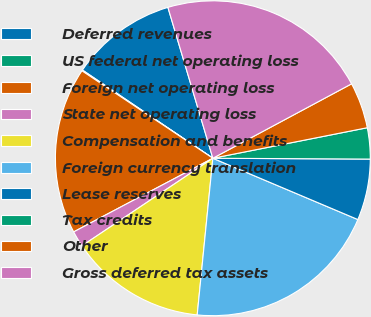Convert chart. <chart><loc_0><loc_0><loc_500><loc_500><pie_chart><fcel>Deferred revenues<fcel>US federal net operating loss<fcel>Foreign net operating loss<fcel>State net operating loss<fcel>Compensation and benefits<fcel>Foreign currency translation<fcel>Lease reserves<fcel>Tax credits<fcel>Other<fcel>Gross deferred tax assets<nl><fcel>10.93%<fcel>0.09%<fcel>17.12%<fcel>1.64%<fcel>14.03%<fcel>20.22%<fcel>6.28%<fcel>3.19%<fcel>4.73%<fcel>21.77%<nl></chart> 